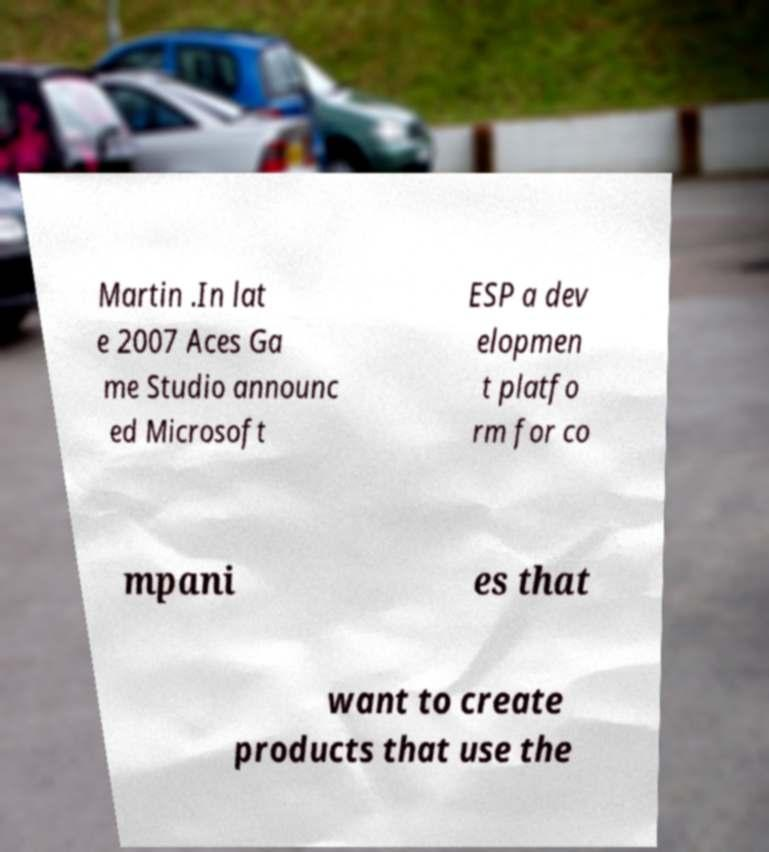Could you assist in decoding the text presented in this image and type it out clearly? Martin .In lat e 2007 Aces Ga me Studio announc ed Microsoft ESP a dev elopmen t platfo rm for co mpani es that want to create products that use the 